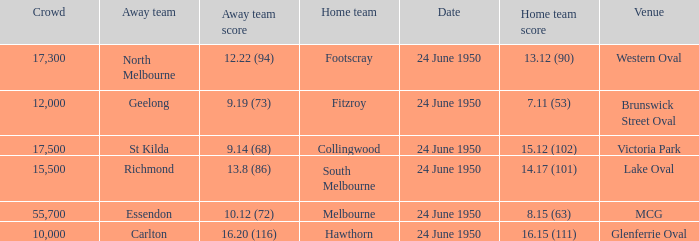In the match where north melbourne was the away team and more than 12,000 spectators were present, who served as the home team? Footscray. Could you parse the entire table? {'header': ['Crowd', 'Away team', 'Away team score', 'Home team', 'Date', 'Home team score', 'Venue'], 'rows': [['17,300', 'North Melbourne', '12.22 (94)', 'Footscray', '24 June 1950', '13.12 (90)', 'Western Oval'], ['12,000', 'Geelong', '9.19 (73)', 'Fitzroy', '24 June 1950', '7.11 (53)', 'Brunswick Street Oval'], ['17,500', 'St Kilda', '9.14 (68)', 'Collingwood', '24 June 1950', '15.12 (102)', 'Victoria Park'], ['15,500', 'Richmond', '13.8 (86)', 'South Melbourne', '24 June 1950', '14.17 (101)', 'Lake Oval'], ['55,700', 'Essendon', '10.12 (72)', 'Melbourne', '24 June 1950', '8.15 (63)', 'MCG'], ['10,000', 'Carlton', '16.20 (116)', 'Hawthorn', '24 June 1950', '16.15 (111)', 'Glenferrie Oval']]} 